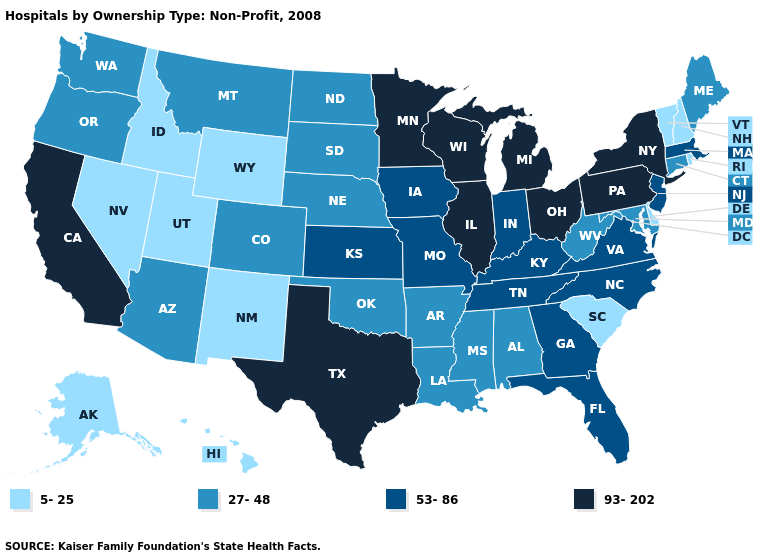What is the value of New Jersey?
Write a very short answer. 53-86. Which states have the lowest value in the MidWest?
Write a very short answer. Nebraska, North Dakota, South Dakota. Does Louisiana have a higher value than South Carolina?
Write a very short answer. Yes. Is the legend a continuous bar?
Quick response, please. No. What is the value of Ohio?
Be succinct. 93-202. Name the states that have a value in the range 27-48?
Be succinct. Alabama, Arizona, Arkansas, Colorado, Connecticut, Louisiana, Maine, Maryland, Mississippi, Montana, Nebraska, North Dakota, Oklahoma, Oregon, South Dakota, Washington, West Virginia. What is the lowest value in states that border Delaware?
Be succinct. 27-48. What is the value of Oklahoma?
Short answer required. 27-48. What is the lowest value in the Northeast?
Short answer required. 5-25. Name the states that have a value in the range 53-86?
Keep it brief. Florida, Georgia, Indiana, Iowa, Kansas, Kentucky, Massachusetts, Missouri, New Jersey, North Carolina, Tennessee, Virginia. Which states have the lowest value in the South?
Write a very short answer. Delaware, South Carolina. Among the states that border South Dakota , does North Dakota have the highest value?
Quick response, please. No. Does the map have missing data?
Concise answer only. No. Among the states that border Maryland , which have the highest value?
Quick response, please. Pennsylvania. Which states hav the highest value in the West?
Answer briefly. California. 